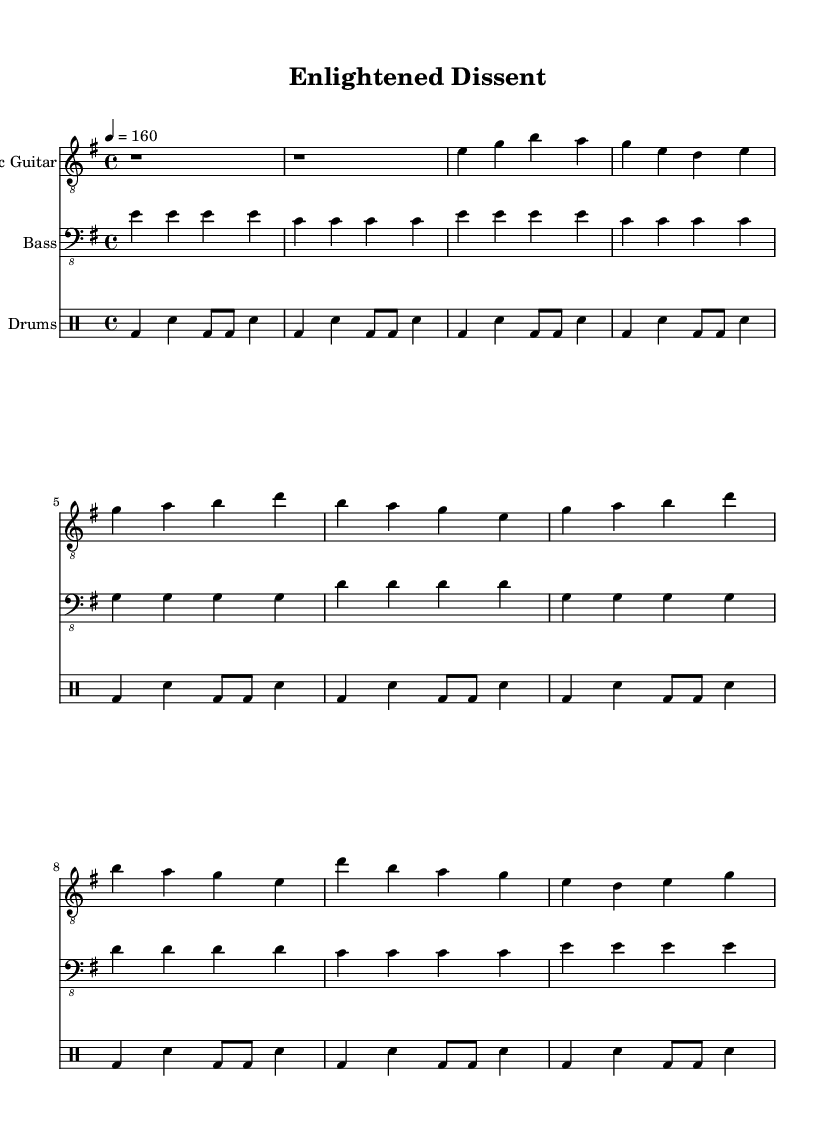What is the key signature of this music? The key signature is indicated at the beginning of the score, showing the music is in E minor, which contains one sharp.
Answer: E minor What is the time signature of this music? The time signature is shown at the beginning of the score as 4/4, indicating four beats per measure.
Answer: 4/4 What is the tempo marking for this piece? The tempo marking indicates the speed of the music, and it is set to 160 beats per minute in the score.
Answer: 160 How many measures are in the chorus section? By counting the measures specifically in the chorus section, there are four measures shown.
Answer: 4 What is the main instrument used in this piece? The primary instrument that leads the musical texture is the electric guitar, as indicated at the start of its staff.
Answer: Electric Guitar How does the bass guitar complement the electric guitar in the verse? The bass guitar mirrors the rhythm and follows the same chord progression as the electric guitar, reinforcing the harmonic structure.
Answer: Mirroring chords What social issue might the title "Enlightened Dissent" suggest? The phrase implies a critique or questioning of societal norms or government policies, common themes in politically charged punk music.
Answer: Critique of society 